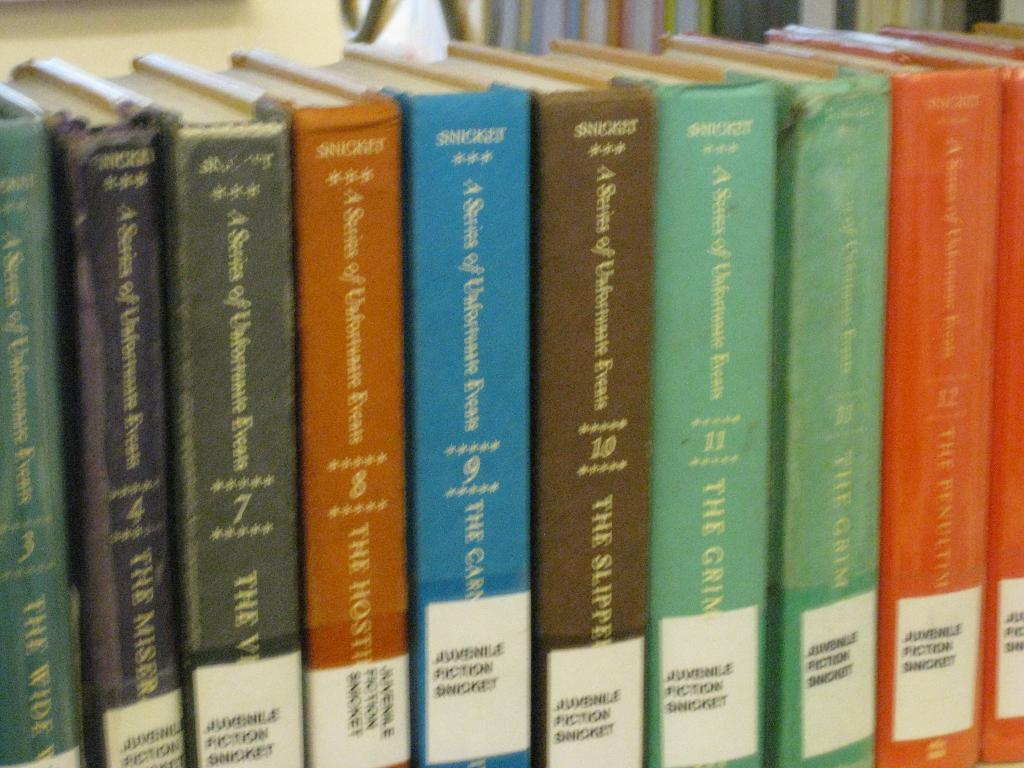Provide a one-sentence caption for the provided image. Colorful books are lined up, all authored by Snicket. 